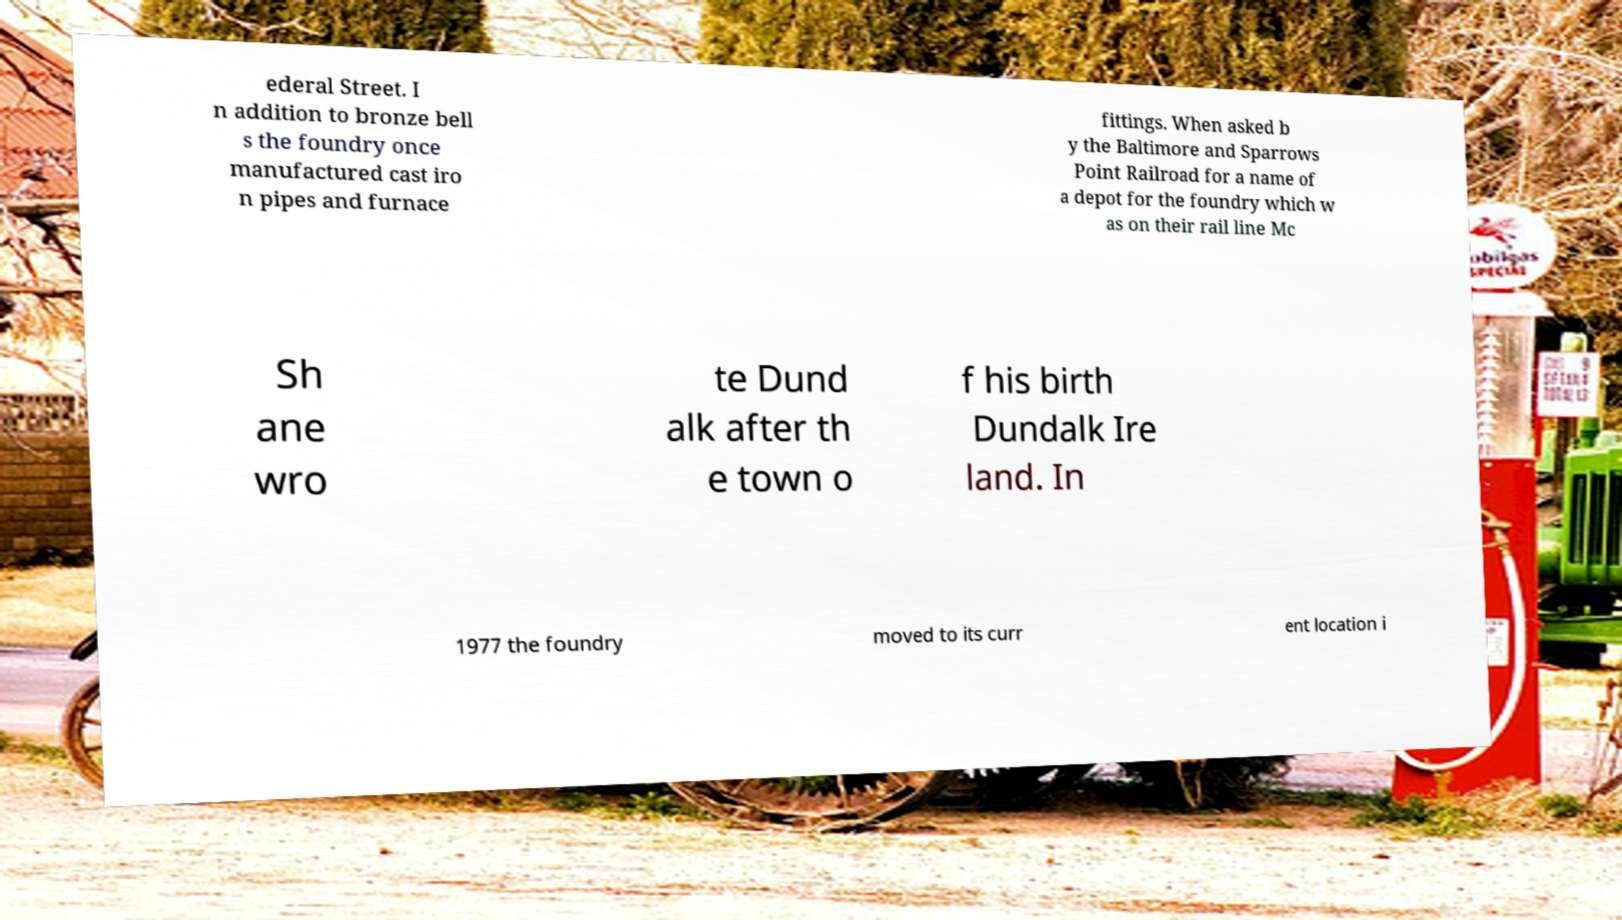Can you read and provide the text displayed in the image?This photo seems to have some interesting text. Can you extract and type it out for me? ederal Street. I n addition to bronze bell s the foundry once manufactured cast iro n pipes and furnace fittings. When asked b y the Baltimore and Sparrows Point Railroad for a name of a depot for the foundry which w as on their rail line Mc Sh ane wro te Dund alk after th e town o f his birth Dundalk Ire land. In 1977 the foundry moved to its curr ent location i 